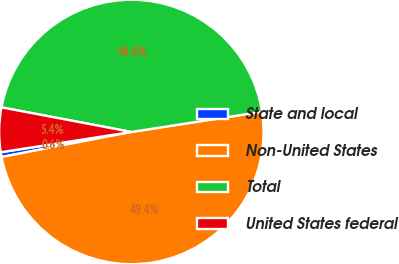Convert chart. <chart><loc_0><loc_0><loc_500><loc_500><pie_chart><fcel>State and local<fcel>Non-United States<fcel>Total<fcel>United States federal<nl><fcel>0.58%<fcel>49.42%<fcel>44.57%<fcel>5.43%<nl></chart> 